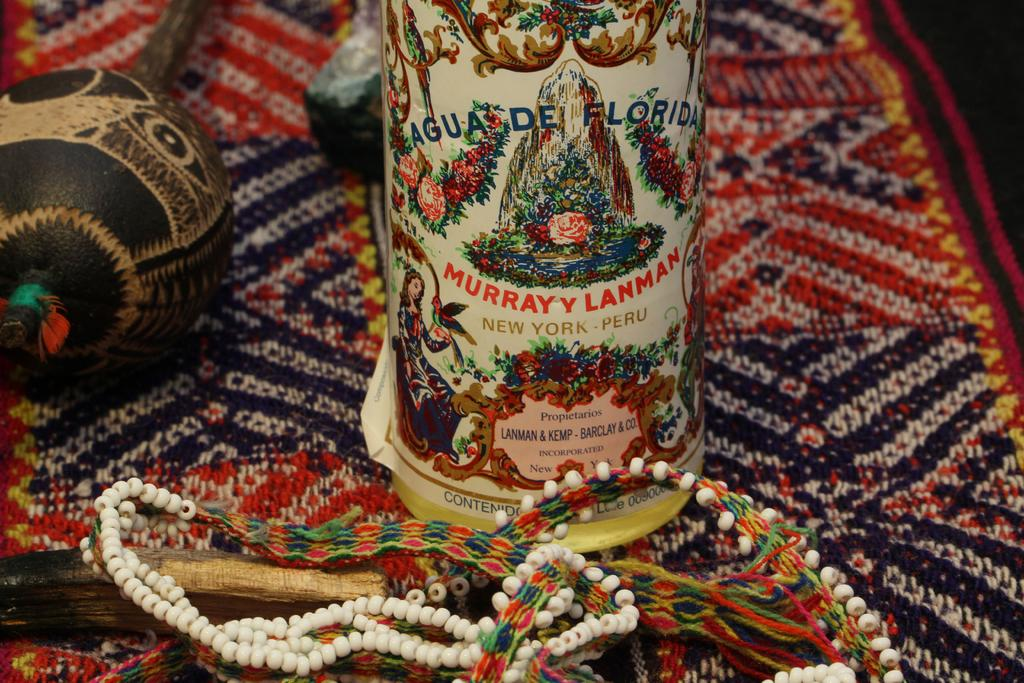What type of accessory is present in the image? There is a necklace in the image. What other object can be seen in the image? There is a bottle in the image. What is the surface on which the necklace and bottle are placed? The objects are on a cloth in the image. What type of ray is visible in the image? There is no ray present in the image. What process is being carried out in the image? The image does not depict a process; it shows a necklace, a bottle, and other items on a cloth. 